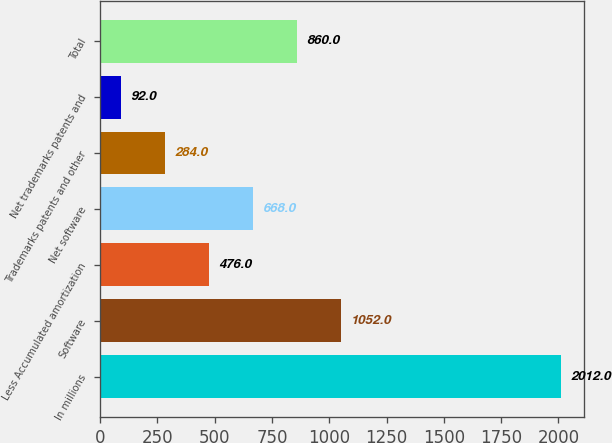<chart> <loc_0><loc_0><loc_500><loc_500><bar_chart><fcel>In millions<fcel>Software<fcel>Less Accumulated amortization<fcel>Net software<fcel>Trademarks patents and other<fcel>Net trademarks patents and<fcel>Total<nl><fcel>2012<fcel>1052<fcel>476<fcel>668<fcel>284<fcel>92<fcel>860<nl></chart> 